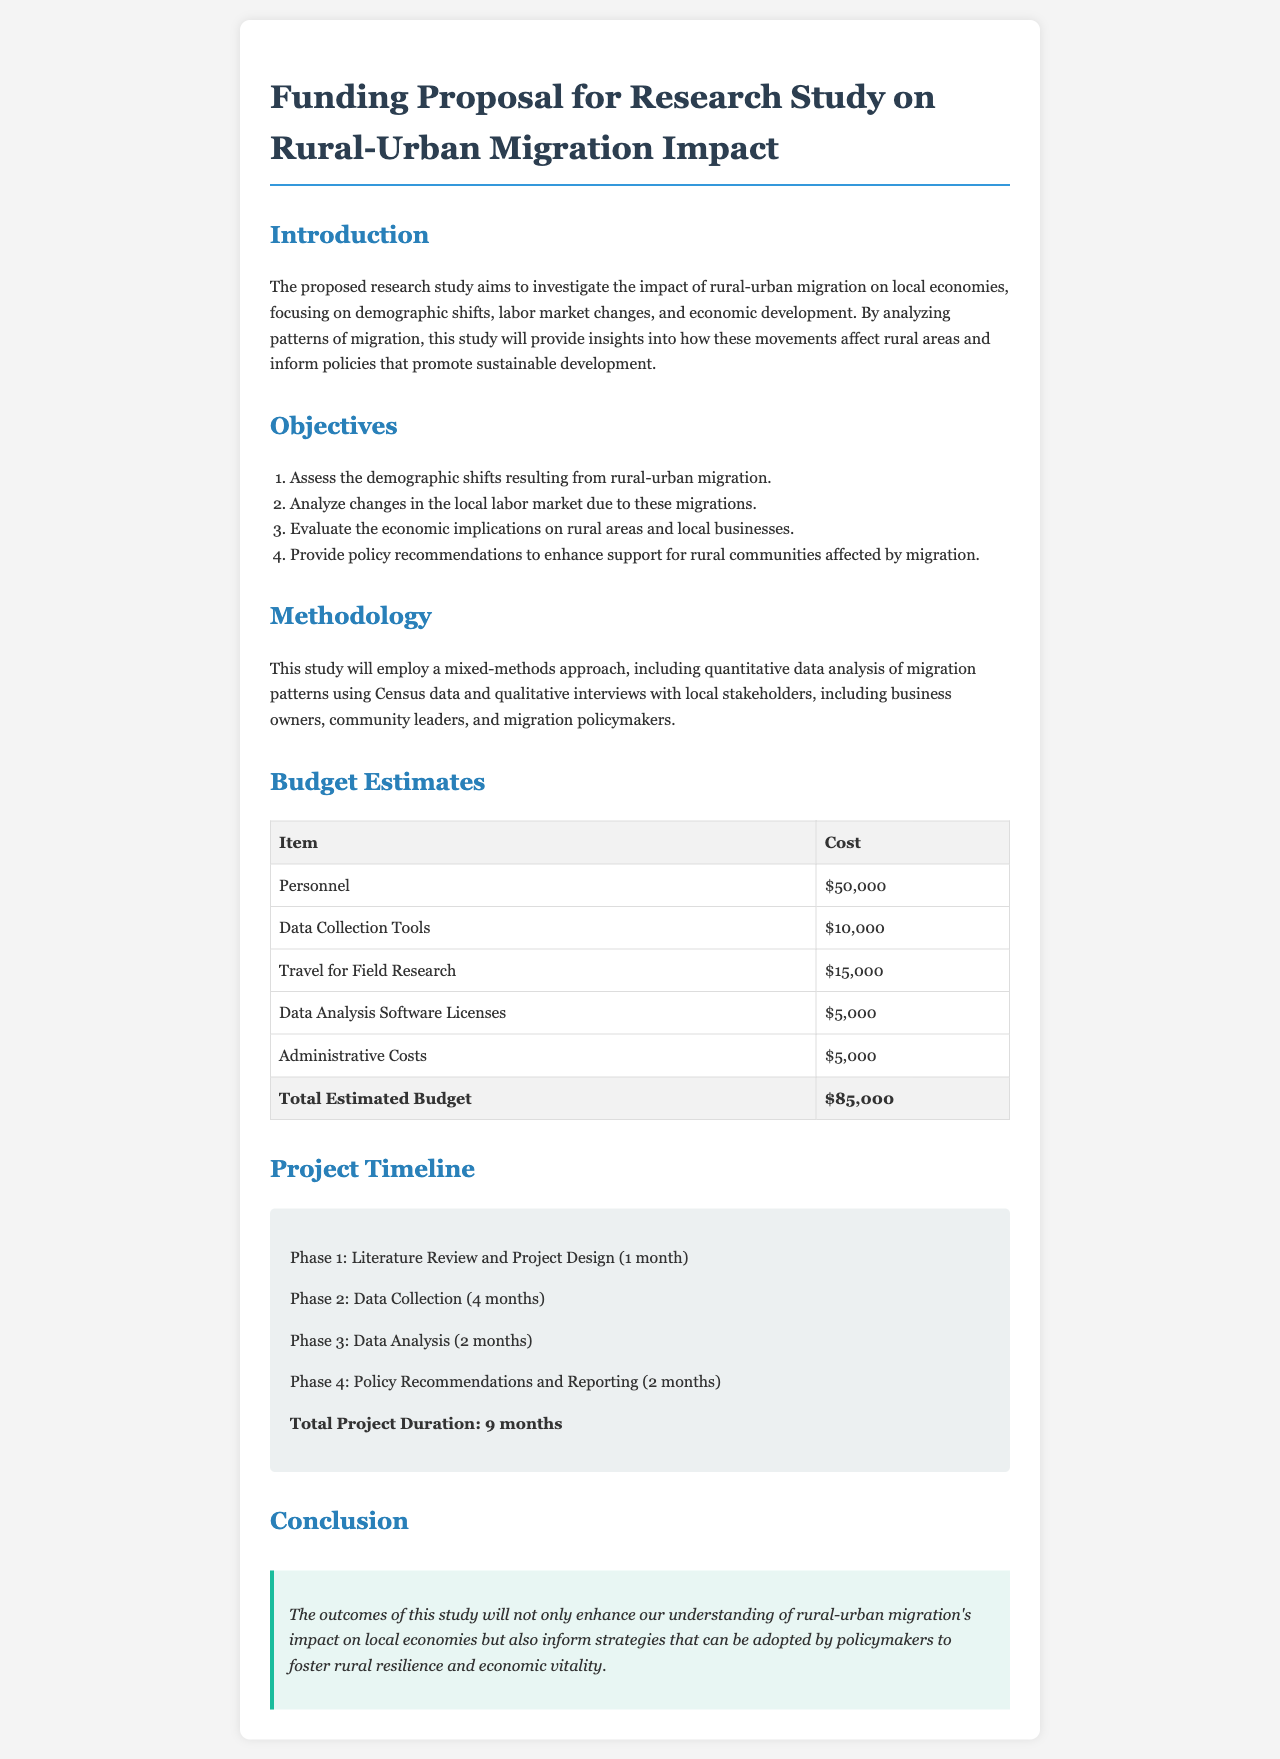What is the total estimated budget? The total estimated budget is provided in the budget estimates section, summing all listed costs.
Answer: $85,000 What is the duration of the project? The total project duration is stated in the project timeline section, combining all phases.
Answer: 9 months Which phase comes first in the project timeline? The first phase is detailed in the project timeline and outlines the initial activities of the study.
Answer: Literature Review and Project Design What is the cost of Data Analysis Software Licenses? The cost for data analysis software licenses is specifically mentioned in the budget estimates table.
Answer: $5,000 What is the objective related to policy recommendations? The objectives include evaluating and providing policy recommendations, which is mentioned in the list of objectives.
Answer: Provide policy recommendations to enhance support for rural communities affected by migration How many months is allocated for data collection? The time allocated for data collection is specified in the project timeline.
Answer: 4 months What types of data will be analyzed in the study? The types of data mentioned in the methodology include quantitative data from Census and qualitative data from interviews.
Answer: Quantitative and qualitative data Who will be interviewed as part of the study? The document lists specific local stakeholders who will be involved in the qualitative aspect of the research.
Answer: Business owners, community leaders, and migration policymakers What is the main aim of the research study? The main aim of the study is outlined in the introduction, focusing on the effects of migration.
Answer: Investigate the impact of rural-urban migration on local economies 